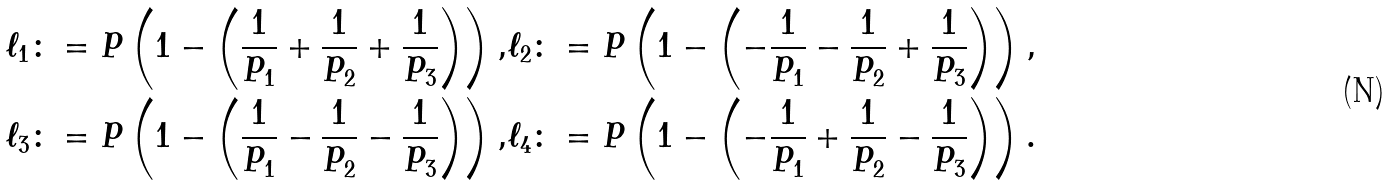<formula> <loc_0><loc_0><loc_500><loc_500>\ell _ { 1 } \colon = P \left ( 1 - \left ( \frac { 1 } { P _ { 1 } } + \frac { 1 } { P _ { 2 } } + \frac { 1 } { P _ { 3 } } \right ) \right ) , & \ell _ { 2 } \colon = P \left ( 1 - \left ( - \frac { 1 } { P _ { 1 } } - \frac { 1 } { P _ { 2 } } + \frac { 1 } { P _ { 3 } } \right ) \right ) , \\ \ell _ { 3 } \colon = P \left ( 1 - \left ( \frac { 1 } { P _ { 1 } } - \frac { 1 } { P _ { 2 } } - \frac { 1 } { P _ { 3 } } \right ) \right ) , & \ell _ { 4 } \colon = P \left ( 1 - \left ( - \frac { 1 } { P _ { 1 } } + \frac { 1 } { P _ { 2 } } - \frac { 1 } { P _ { 3 } } \right ) \right ) .</formula> 